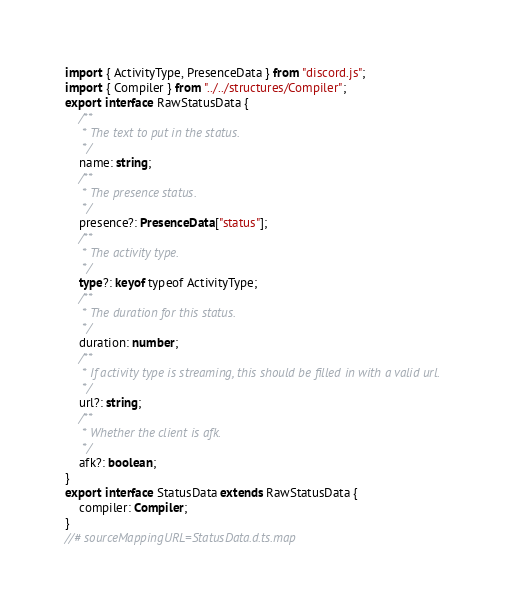Convert code to text. <code><loc_0><loc_0><loc_500><loc_500><_TypeScript_>import { ActivityType, PresenceData } from "discord.js";
import { Compiler } from "../../structures/Compiler";
export interface RawStatusData {
    /**
     * The text to put in the status.
     */
    name: string;
    /**
     * The presence status.
     */
    presence?: PresenceData["status"];
    /**
     * The activity type.
     */
    type?: keyof typeof ActivityType;
    /**
     * The duration for this status.
     */
    duration: number;
    /**
     * If activity type is streaming, this should be filled in with a valid url.
     */
    url?: string;
    /**
     * Whether the client is afk.
     */
    afk?: boolean;
}
export interface StatusData extends RawStatusData {
    compiler: Compiler;
}
//# sourceMappingURL=StatusData.d.ts.map</code> 